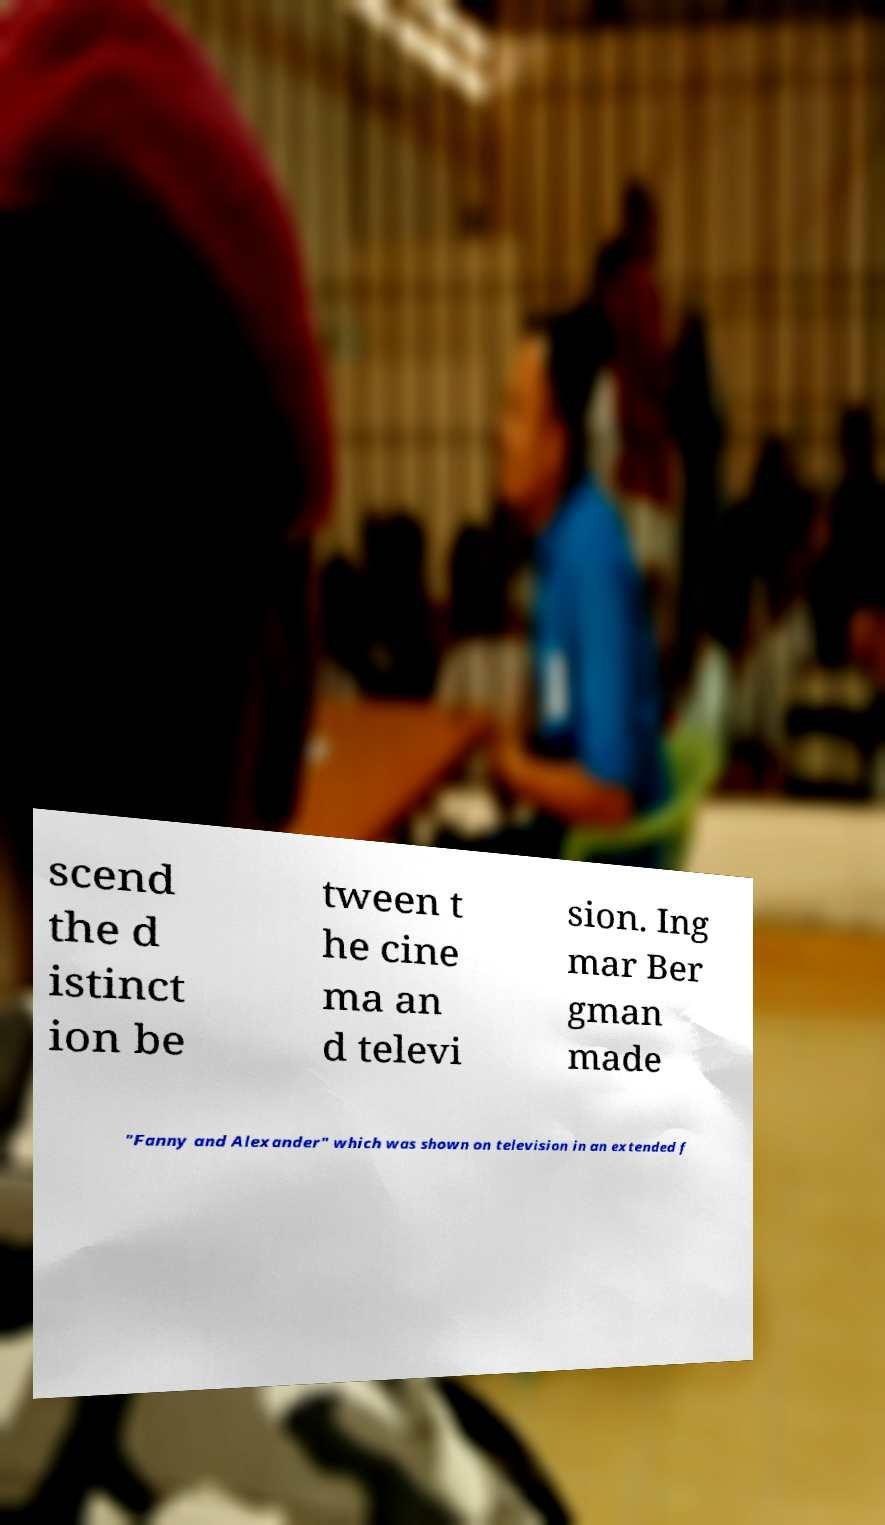Please read and relay the text visible in this image. What does it say? scend the d istinct ion be tween t he cine ma an d televi sion. Ing mar Ber gman made "Fanny and Alexander" which was shown on television in an extended f 